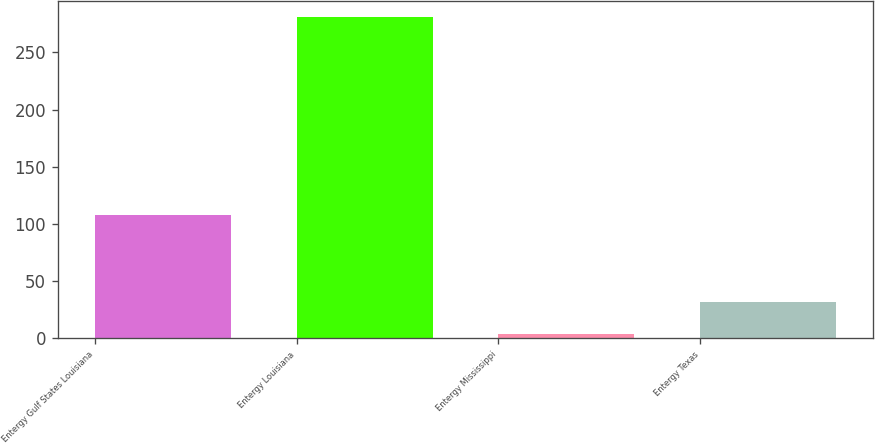Convert chart to OTSL. <chart><loc_0><loc_0><loc_500><loc_500><bar_chart><fcel>Entergy Gulf States Louisiana<fcel>Entergy Louisiana<fcel>Entergy Mississippi<fcel>Entergy Texas<nl><fcel>107.9<fcel>281.3<fcel>3.8<fcel>31.55<nl></chart> 